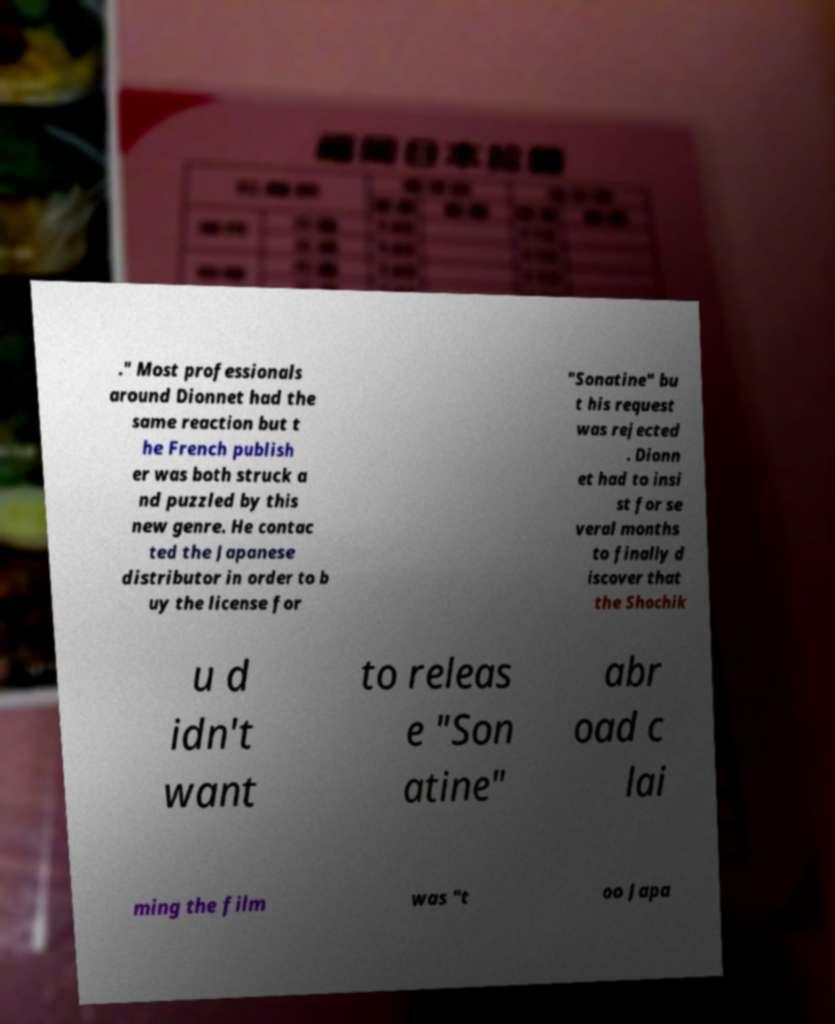Could you extract and type out the text from this image? ." Most professionals around Dionnet had the same reaction but t he French publish er was both struck a nd puzzled by this new genre. He contac ted the Japanese distributor in order to b uy the license for "Sonatine" bu t his request was rejected . Dionn et had to insi st for se veral months to finally d iscover that the Shochik u d idn't want to releas e "Son atine" abr oad c lai ming the film was "t oo Japa 